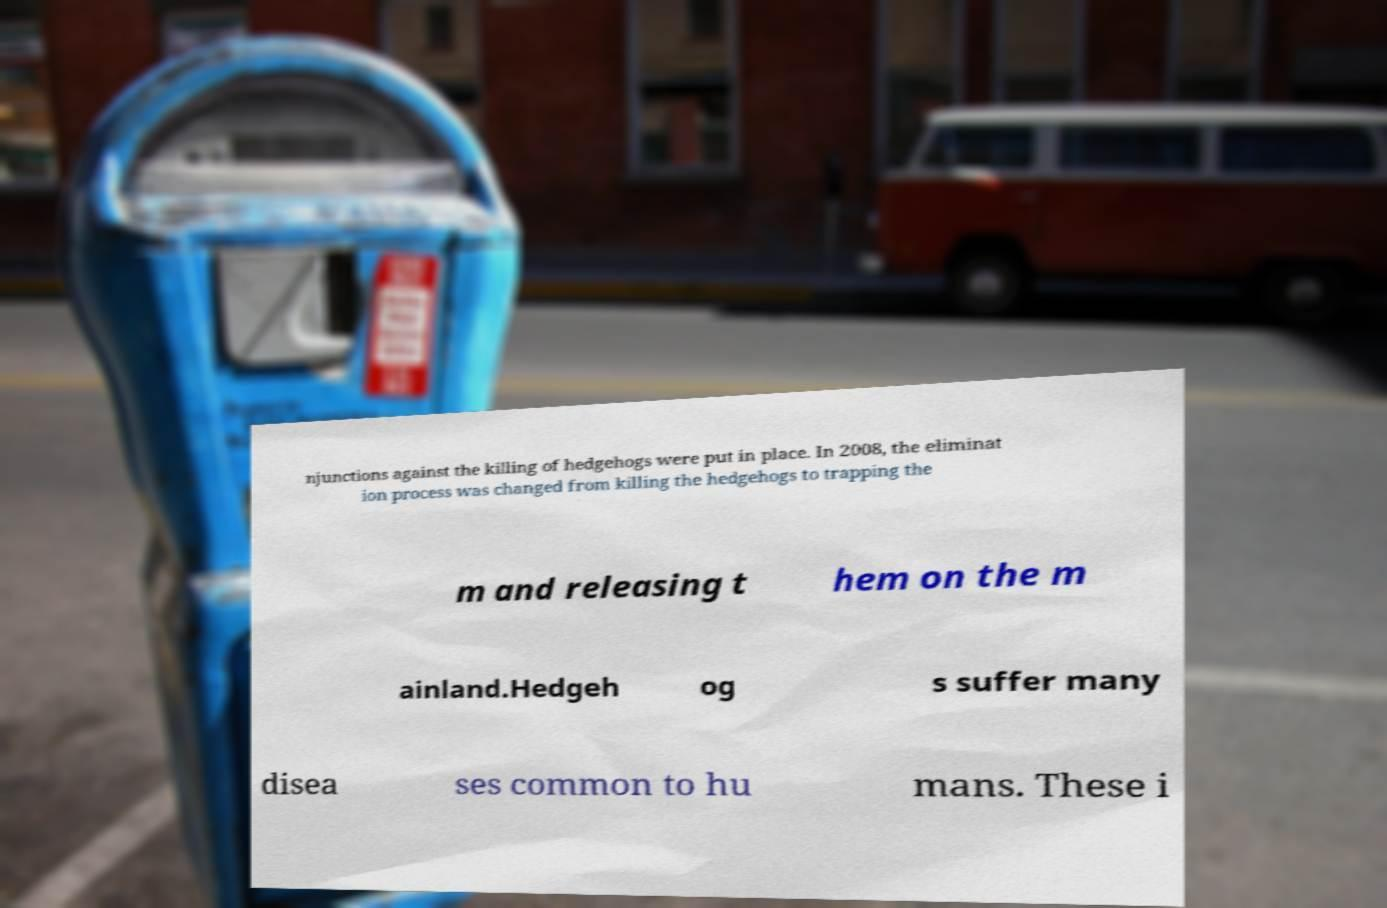What messages or text are displayed in this image? I need them in a readable, typed format. njunctions against the killing of hedgehogs were put in place. In 2008, the eliminat ion process was changed from killing the hedgehogs to trapping the m and releasing t hem on the m ainland.Hedgeh og s suffer many disea ses common to hu mans. These i 